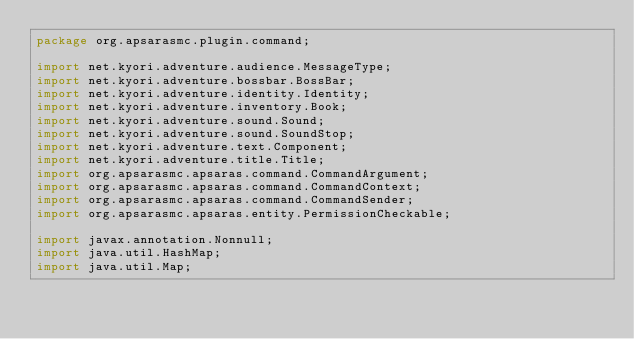Convert code to text. <code><loc_0><loc_0><loc_500><loc_500><_Java_>package org.apsarasmc.plugin.command;

import net.kyori.adventure.audience.MessageType;
import net.kyori.adventure.bossbar.BossBar;
import net.kyori.adventure.identity.Identity;
import net.kyori.adventure.inventory.Book;
import net.kyori.adventure.sound.Sound;
import net.kyori.adventure.sound.SoundStop;
import net.kyori.adventure.text.Component;
import net.kyori.adventure.title.Title;
import org.apsarasmc.apsaras.command.CommandArgument;
import org.apsarasmc.apsaras.command.CommandContext;
import org.apsarasmc.apsaras.command.CommandSender;
import org.apsarasmc.apsaras.entity.PermissionCheckable;

import javax.annotation.Nonnull;
import java.util.HashMap;
import java.util.Map;
</code> 